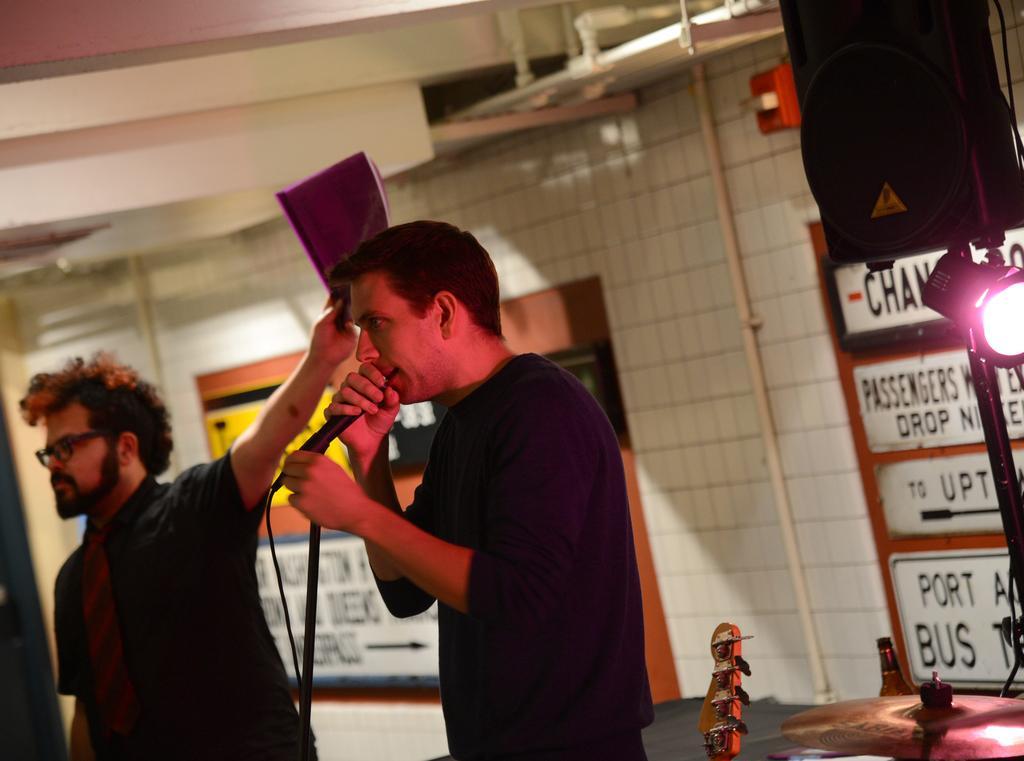Can you describe this image briefly? The person wearing blue shirt is standing and singing in front of a mic and there is another person standing and holding a file in his hand. 